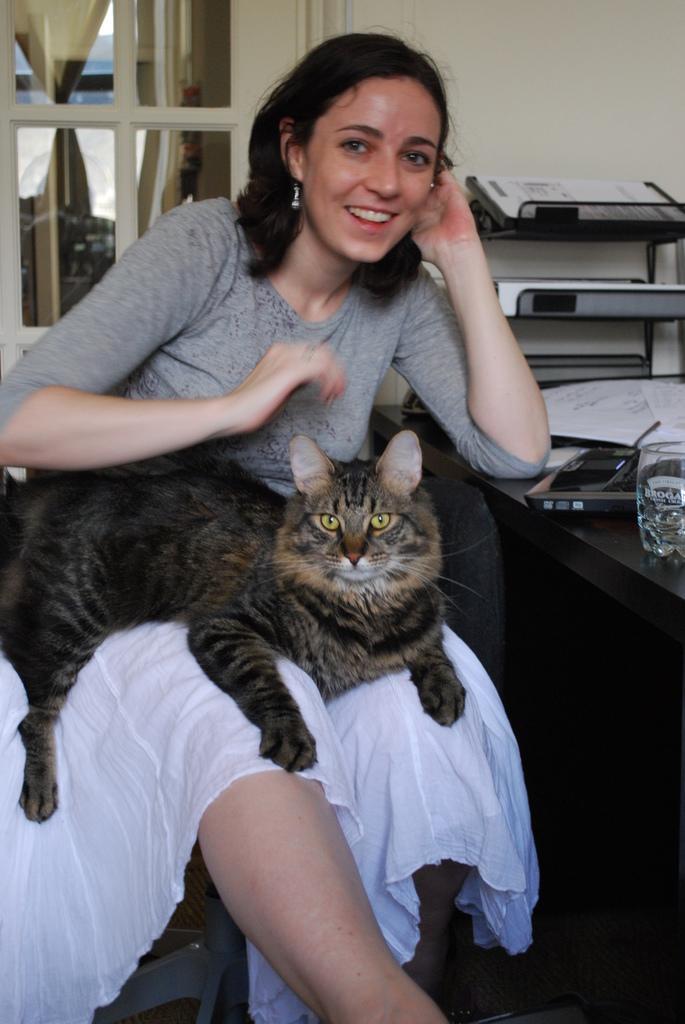Describe this image in one or two sentences. In this picture there is a woman sitting and smiling and there is a cat sitting on the woman. On the right side of the image there are papers and there is a device and glass on the table. At the back there are objects in the stand and there is a window and there is a curtain and wall. At the bottom there is a mat. 